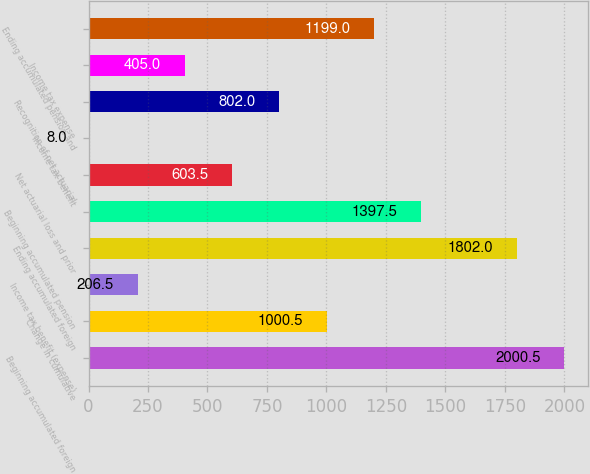Convert chart. <chart><loc_0><loc_0><loc_500><loc_500><bar_chart><fcel>Beginning accumulated foreign<fcel>Change in cumulative<fcel>Income tax benefit (expense)<fcel>Ending accumulated foreign<fcel>Beginning accumulated pension<fcel>Net actuarial loss and prior<fcel>Income tax benefit<fcel>Recognition of net actuarial<fcel>Income tax expense<fcel>Ending accumulated pension and<nl><fcel>2000.5<fcel>1000.5<fcel>206.5<fcel>1802<fcel>1397.5<fcel>603.5<fcel>8<fcel>802<fcel>405<fcel>1199<nl></chart> 